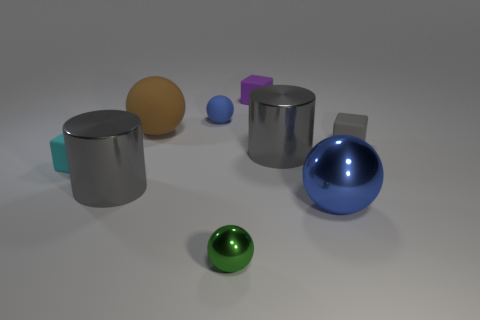Subtract all blue balls. How many were subtracted if there are1blue balls left? 1 Subtract all tiny blue rubber spheres. How many spheres are left? 3 Subtract 3 cubes. How many cubes are left? 0 Add 1 blue metallic cylinders. How many objects exist? 10 Subtract all cyan cubes. How many cubes are left? 2 Subtract all cylinders. How many objects are left? 7 Subtract all gray cylinders. How many blue balls are left? 2 Subtract all red blocks. Subtract all brown balls. How many blocks are left? 3 Subtract all large yellow blocks. Subtract all blue metal objects. How many objects are left? 8 Add 2 small rubber cubes. How many small rubber cubes are left? 5 